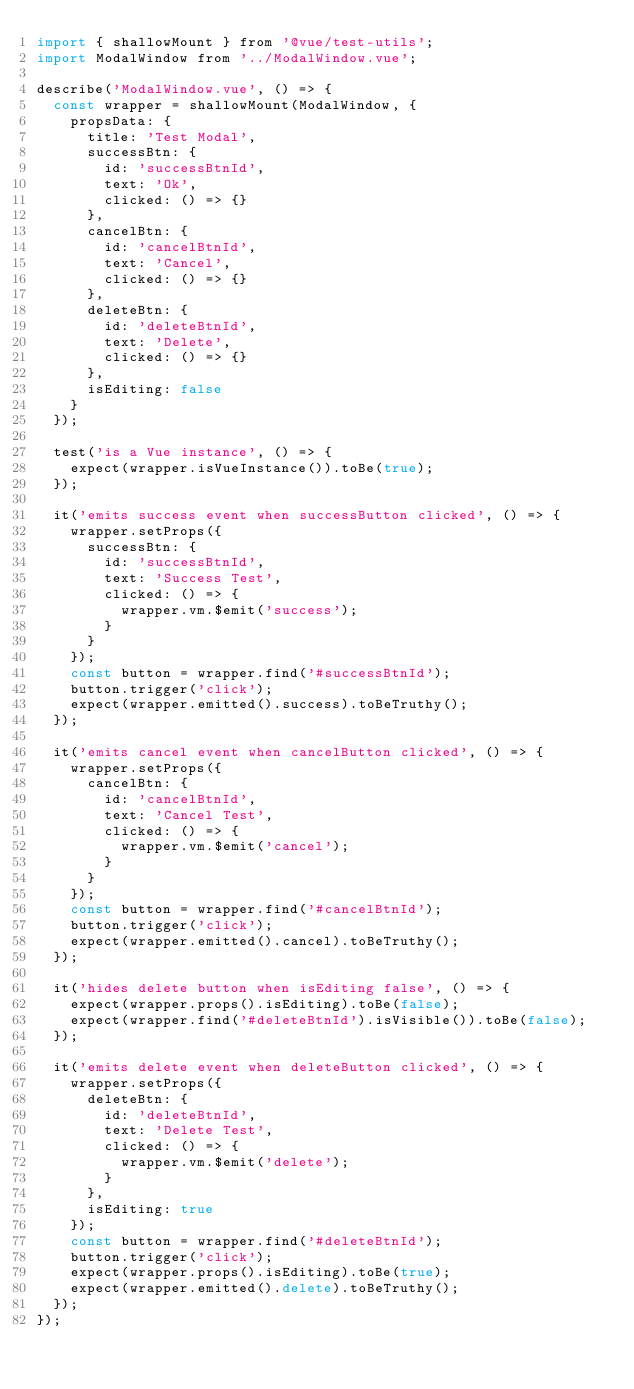<code> <loc_0><loc_0><loc_500><loc_500><_JavaScript_>import { shallowMount } from '@vue/test-utils';
import ModalWindow from '../ModalWindow.vue';

describe('ModalWindow.vue', () => {
  const wrapper = shallowMount(ModalWindow, {
    propsData: {
      title: 'Test Modal',
      successBtn: {
        id: 'successBtnId',
        text: 'Ok',
        clicked: () => {}
      },
      cancelBtn: {
        id: 'cancelBtnId',
        text: 'Cancel',
        clicked: () => {}
      },
      deleteBtn: {
        id: 'deleteBtnId',
        text: 'Delete',
        clicked: () => {}
      },
      isEditing: false
    }
  });

  test('is a Vue instance', () => {
    expect(wrapper.isVueInstance()).toBe(true);
  });

  it('emits success event when successButton clicked', () => {
    wrapper.setProps({
      successBtn: {
        id: 'successBtnId',
        text: 'Success Test',
        clicked: () => {
          wrapper.vm.$emit('success');
        }
      }
    });
    const button = wrapper.find('#successBtnId');
    button.trigger('click');
    expect(wrapper.emitted().success).toBeTruthy();
  });

  it('emits cancel event when cancelButton clicked', () => {
    wrapper.setProps({
      cancelBtn: {
        id: 'cancelBtnId',
        text: 'Cancel Test',
        clicked: () => {
          wrapper.vm.$emit('cancel');
        }
      }
    });
    const button = wrapper.find('#cancelBtnId');
    button.trigger('click');
    expect(wrapper.emitted().cancel).toBeTruthy();
  });

  it('hides delete button when isEditing false', () => {
    expect(wrapper.props().isEditing).toBe(false);
    expect(wrapper.find('#deleteBtnId').isVisible()).toBe(false);
  });

  it('emits delete event when deleteButton clicked', () => {
    wrapper.setProps({
      deleteBtn: {
        id: 'deleteBtnId',
        text: 'Delete Test',
        clicked: () => {
          wrapper.vm.$emit('delete');
        }
      },
      isEditing: true
    });
    const button = wrapper.find('#deleteBtnId');
    button.trigger('click');
    expect(wrapper.props().isEditing).toBe(true);
    expect(wrapper.emitted().delete).toBeTruthy();
  });
});
</code> 